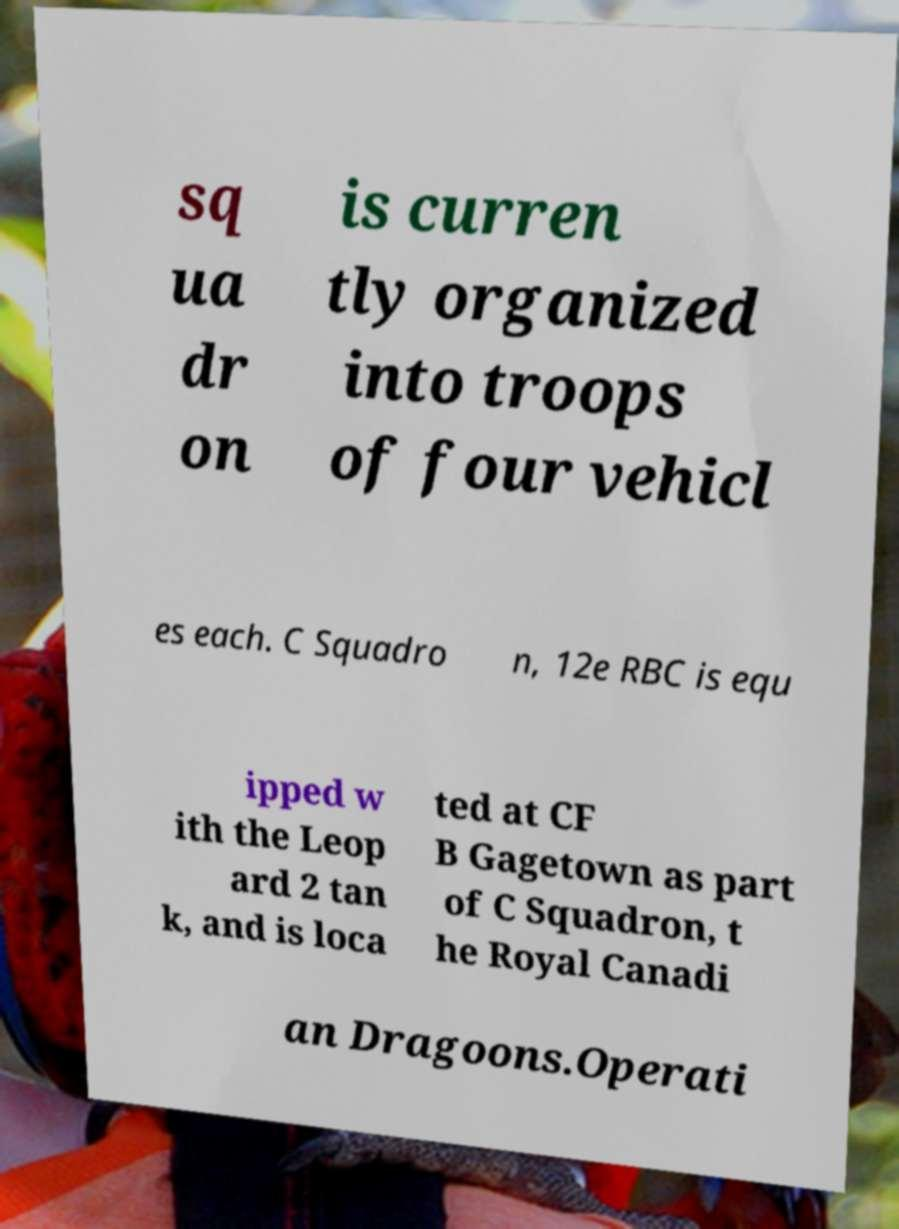What messages or text are displayed in this image? I need them in a readable, typed format. sq ua dr on is curren tly organized into troops of four vehicl es each. C Squadro n, 12e RBC is equ ipped w ith the Leop ard 2 tan k, and is loca ted at CF B Gagetown as part of C Squadron, t he Royal Canadi an Dragoons.Operati 